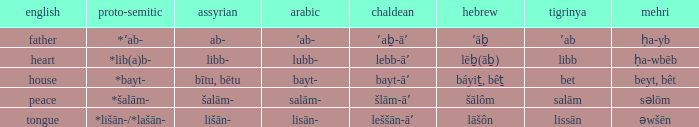Write the full table. {'header': ['english', 'proto-semitic', 'assyrian', 'arabic', 'chaldean', 'hebrew', 'tigrinya', 'mehri'], 'rows': [['father', '*ʼab-', 'ab-', 'ʼab-', 'ʼaḇ-āʼ', 'ʼāḇ', 'ʼab', 'ḥa-yb'], ['heart', '*lib(a)b-', 'libb-', 'lubb-', 'lebb-āʼ', 'lēḇ(āḇ)', 'libb', 'ḥa-wbēb'], ['house', '*bayt-', 'bītu, bētu', 'bayt-', 'bayt-āʼ', 'báyiṯ, bêṯ', 'bet', 'beyt, bêt'], ['peace', '*šalām-', 'šalām-', 'salām-', 'šlām-āʼ', 'šālôm', 'salām', 'səlōm'], ['tongue', '*lišān-/*lašān-', 'lišān-', 'lisān-', 'leššān-āʼ', 'lāšôn', 'lissān', 'əwšēn']]} If the proto-semitic is *bayt-, what are the geez? Bet. 